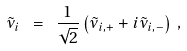Convert formula to latex. <formula><loc_0><loc_0><loc_500><loc_500>\tilde { \nu } _ { i } \ = \ \frac { 1 } { \sqrt { 2 } } \left ( \tilde { \nu } _ { i , + } + i \tilde { \nu } _ { i , - } \right ) \, ,</formula> 